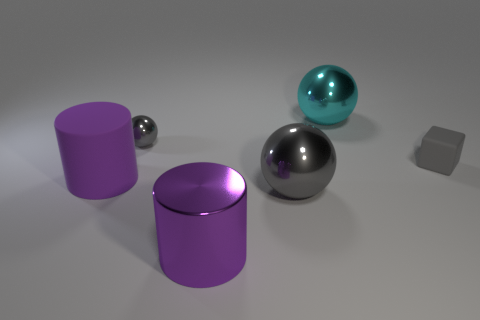Are there any metal objects that have the same color as the matte block?
Provide a short and direct response. Yes. There is a big thing on the left side of the purple metal cylinder; does it have the same color as the big metal cylinder to the left of the small rubber block?
Offer a very short reply. Yes. The object that is the same color as the matte cylinder is what size?
Your answer should be compact. Large. Is there a big cylinder behind the purple cylinder behind the large gray sphere?
Your answer should be very brief. No. What number of rubber things are purple cylinders or cubes?
Your answer should be compact. 2. There is a thing that is on the right side of the purple shiny thing and in front of the gray matte block; what is its material?
Your answer should be very brief. Metal. There is a big metal ball to the right of the gray sphere that is in front of the small gray ball; is there a purple thing in front of it?
Provide a succinct answer. Yes. There is a tiny gray thing that is the same material as the big gray object; what is its shape?
Give a very brief answer. Sphere. Is the number of large gray things that are to the right of the big gray metal object less than the number of large cylinders on the left side of the large cyan shiny thing?
Your answer should be very brief. Yes. What number of small objects are purple metallic things or gray balls?
Give a very brief answer. 1. 